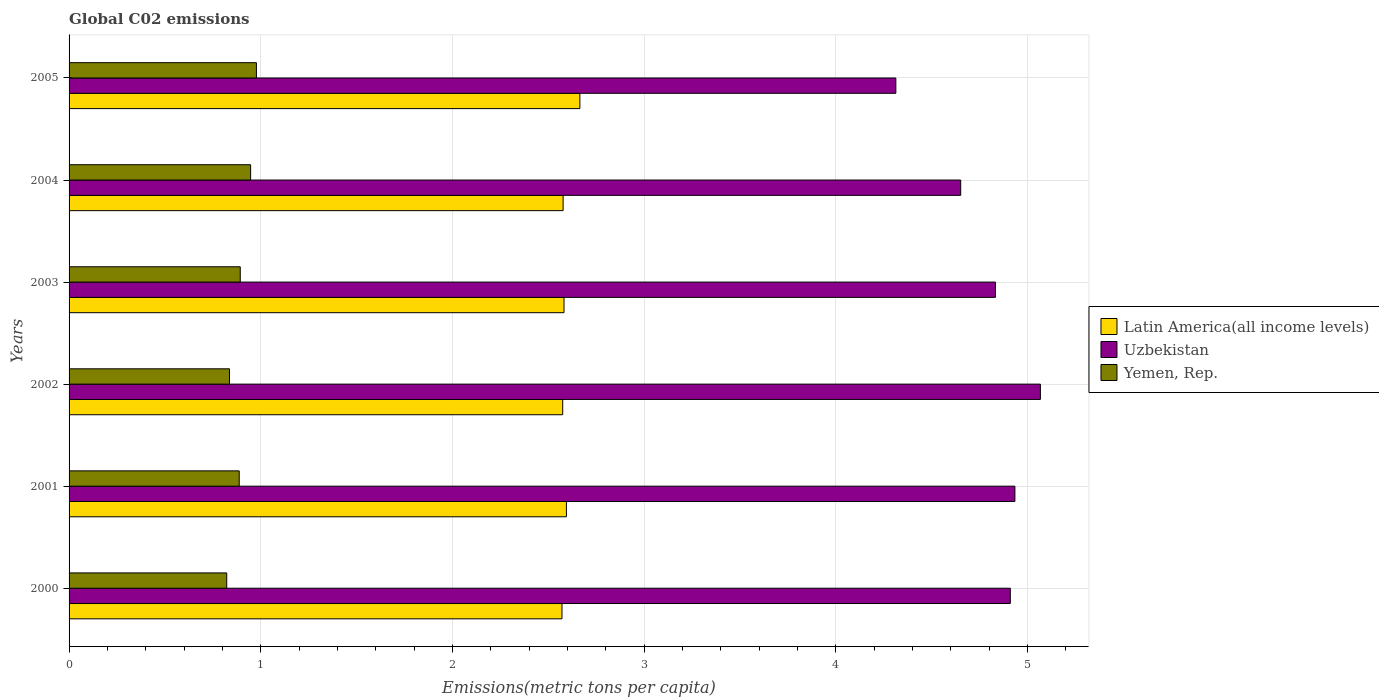How many bars are there on the 4th tick from the top?
Provide a short and direct response. 3. In how many cases, is the number of bars for a given year not equal to the number of legend labels?
Your answer should be compact. 0. What is the amount of CO2 emitted in in Uzbekistan in 2005?
Your answer should be compact. 4.31. Across all years, what is the maximum amount of CO2 emitted in in Latin America(all income levels)?
Keep it short and to the point. 2.67. Across all years, what is the minimum amount of CO2 emitted in in Latin America(all income levels)?
Make the answer very short. 2.57. In which year was the amount of CO2 emitted in in Yemen, Rep. maximum?
Your answer should be compact. 2005. What is the total amount of CO2 emitted in in Yemen, Rep. in the graph?
Give a very brief answer. 5.37. What is the difference between the amount of CO2 emitted in in Yemen, Rep. in 2001 and that in 2005?
Your answer should be compact. -0.09. What is the difference between the amount of CO2 emitted in in Uzbekistan in 2005 and the amount of CO2 emitted in in Latin America(all income levels) in 2003?
Make the answer very short. 1.73. What is the average amount of CO2 emitted in in Latin America(all income levels) per year?
Make the answer very short. 2.59. In the year 2000, what is the difference between the amount of CO2 emitted in in Yemen, Rep. and amount of CO2 emitted in in Latin America(all income levels)?
Make the answer very short. -1.75. In how many years, is the amount of CO2 emitted in in Latin America(all income levels) greater than 0.4 metric tons per capita?
Offer a very short reply. 6. What is the ratio of the amount of CO2 emitted in in Latin America(all income levels) in 2001 to that in 2003?
Ensure brevity in your answer.  1. Is the difference between the amount of CO2 emitted in in Yemen, Rep. in 2002 and 2004 greater than the difference between the amount of CO2 emitted in in Latin America(all income levels) in 2002 and 2004?
Provide a succinct answer. No. What is the difference between the highest and the second highest amount of CO2 emitted in in Latin America(all income levels)?
Your answer should be compact. 0.07. What is the difference between the highest and the lowest amount of CO2 emitted in in Uzbekistan?
Keep it short and to the point. 0.75. In how many years, is the amount of CO2 emitted in in Latin America(all income levels) greater than the average amount of CO2 emitted in in Latin America(all income levels) taken over all years?
Give a very brief answer. 2. What does the 3rd bar from the top in 2003 represents?
Offer a very short reply. Latin America(all income levels). What does the 1st bar from the bottom in 2004 represents?
Offer a very short reply. Latin America(all income levels). Is it the case that in every year, the sum of the amount of CO2 emitted in in Yemen, Rep. and amount of CO2 emitted in in Uzbekistan is greater than the amount of CO2 emitted in in Latin America(all income levels)?
Provide a short and direct response. Yes. How many bars are there?
Make the answer very short. 18. Are all the bars in the graph horizontal?
Provide a short and direct response. Yes. Are the values on the major ticks of X-axis written in scientific E-notation?
Your answer should be compact. No. Does the graph contain grids?
Make the answer very short. Yes. Where does the legend appear in the graph?
Offer a very short reply. Center right. What is the title of the graph?
Provide a short and direct response. Global C02 emissions. Does "Moldova" appear as one of the legend labels in the graph?
Your answer should be very brief. No. What is the label or title of the X-axis?
Offer a very short reply. Emissions(metric tons per capita). What is the label or title of the Y-axis?
Give a very brief answer. Years. What is the Emissions(metric tons per capita) in Latin America(all income levels) in 2000?
Offer a very short reply. 2.57. What is the Emissions(metric tons per capita) of Uzbekistan in 2000?
Offer a terse response. 4.91. What is the Emissions(metric tons per capita) in Yemen, Rep. in 2000?
Your answer should be very brief. 0.82. What is the Emissions(metric tons per capita) of Latin America(all income levels) in 2001?
Your answer should be compact. 2.59. What is the Emissions(metric tons per capita) in Uzbekistan in 2001?
Offer a very short reply. 4.94. What is the Emissions(metric tons per capita) of Yemen, Rep. in 2001?
Your answer should be compact. 0.89. What is the Emissions(metric tons per capita) in Latin America(all income levels) in 2002?
Give a very brief answer. 2.58. What is the Emissions(metric tons per capita) in Uzbekistan in 2002?
Your response must be concise. 5.07. What is the Emissions(metric tons per capita) in Yemen, Rep. in 2002?
Your answer should be very brief. 0.84. What is the Emissions(metric tons per capita) of Latin America(all income levels) in 2003?
Give a very brief answer. 2.58. What is the Emissions(metric tons per capita) in Uzbekistan in 2003?
Your response must be concise. 4.83. What is the Emissions(metric tons per capita) in Yemen, Rep. in 2003?
Provide a succinct answer. 0.89. What is the Emissions(metric tons per capita) of Latin America(all income levels) in 2004?
Keep it short and to the point. 2.58. What is the Emissions(metric tons per capita) of Uzbekistan in 2004?
Ensure brevity in your answer.  4.65. What is the Emissions(metric tons per capita) in Yemen, Rep. in 2004?
Keep it short and to the point. 0.95. What is the Emissions(metric tons per capita) of Latin America(all income levels) in 2005?
Provide a short and direct response. 2.67. What is the Emissions(metric tons per capita) of Uzbekistan in 2005?
Provide a short and direct response. 4.31. What is the Emissions(metric tons per capita) in Yemen, Rep. in 2005?
Your answer should be compact. 0.98. Across all years, what is the maximum Emissions(metric tons per capita) in Latin America(all income levels)?
Provide a succinct answer. 2.67. Across all years, what is the maximum Emissions(metric tons per capita) of Uzbekistan?
Ensure brevity in your answer.  5.07. Across all years, what is the maximum Emissions(metric tons per capita) of Yemen, Rep.?
Offer a very short reply. 0.98. Across all years, what is the minimum Emissions(metric tons per capita) of Latin America(all income levels)?
Your response must be concise. 2.57. Across all years, what is the minimum Emissions(metric tons per capita) in Uzbekistan?
Make the answer very short. 4.31. Across all years, what is the minimum Emissions(metric tons per capita) of Yemen, Rep.?
Ensure brevity in your answer.  0.82. What is the total Emissions(metric tons per capita) in Latin America(all income levels) in the graph?
Give a very brief answer. 15.57. What is the total Emissions(metric tons per capita) of Uzbekistan in the graph?
Give a very brief answer. 28.71. What is the total Emissions(metric tons per capita) of Yemen, Rep. in the graph?
Make the answer very short. 5.37. What is the difference between the Emissions(metric tons per capita) of Latin America(all income levels) in 2000 and that in 2001?
Your answer should be compact. -0.02. What is the difference between the Emissions(metric tons per capita) in Uzbekistan in 2000 and that in 2001?
Your response must be concise. -0.02. What is the difference between the Emissions(metric tons per capita) of Yemen, Rep. in 2000 and that in 2001?
Your answer should be very brief. -0.07. What is the difference between the Emissions(metric tons per capita) in Latin America(all income levels) in 2000 and that in 2002?
Your answer should be compact. -0. What is the difference between the Emissions(metric tons per capita) in Uzbekistan in 2000 and that in 2002?
Your answer should be compact. -0.16. What is the difference between the Emissions(metric tons per capita) of Yemen, Rep. in 2000 and that in 2002?
Your response must be concise. -0.01. What is the difference between the Emissions(metric tons per capita) of Latin America(all income levels) in 2000 and that in 2003?
Your response must be concise. -0.01. What is the difference between the Emissions(metric tons per capita) in Uzbekistan in 2000 and that in 2003?
Offer a terse response. 0.08. What is the difference between the Emissions(metric tons per capita) of Yemen, Rep. in 2000 and that in 2003?
Provide a succinct answer. -0.07. What is the difference between the Emissions(metric tons per capita) in Latin America(all income levels) in 2000 and that in 2004?
Make the answer very short. -0.01. What is the difference between the Emissions(metric tons per capita) in Uzbekistan in 2000 and that in 2004?
Keep it short and to the point. 0.26. What is the difference between the Emissions(metric tons per capita) in Yemen, Rep. in 2000 and that in 2004?
Offer a terse response. -0.12. What is the difference between the Emissions(metric tons per capita) of Latin America(all income levels) in 2000 and that in 2005?
Your answer should be compact. -0.09. What is the difference between the Emissions(metric tons per capita) of Uzbekistan in 2000 and that in 2005?
Offer a very short reply. 0.6. What is the difference between the Emissions(metric tons per capita) of Yemen, Rep. in 2000 and that in 2005?
Offer a very short reply. -0.15. What is the difference between the Emissions(metric tons per capita) of Latin America(all income levels) in 2001 and that in 2002?
Provide a short and direct response. 0.02. What is the difference between the Emissions(metric tons per capita) in Uzbekistan in 2001 and that in 2002?
Give a very brief answer. -0.13. What is the difference between the Emissions(metric tons per capita) in Yemen, Rep. in 2001 and that in 2002?
Provide a succinct answer. 0.05. What is the difference between the Emissions(metric tons per capita) in Latin America(all income levels) in 2001 and that in 2003?
Keep it short and to the point. 0.01. What is the difference between the Emissions(metric tons per capita) of Uzbekistan in 2001 and that in 2003?
Offer a terse response. 0.1. What is the difference between the Emissions(metric tons per capita) of Yemen, Rep. in 2001 and that in 2003?
Offer a terse response. -0.01. What is the difference between the Emissions(metric tons per capita) of Latin America(all income levels) in 2001 and that in 2004?
Give a very brief answer. 0.02. What is the difference between the Emissions(metric tons per capita) of Uzbekistan in 2001 and that in 2004?
Provide a short and direct response. 0.28. What is the difference between the Emissions(metric tons per capita) in Yemen, Rep. in 2001 and that in 2004?
Your response must be concise. -0.06. What is the difference between the Emissions(metric tons per capita) in Latin America(all income levels) in 2001 and that in 2005?
Provide a short and direct response. -0.07. What is the difference between the Emissions(metric tons per capita) in Uzbekistan in 2001 and that in 2005?
Your response must be concise. 0.62. What is the difference between the Emissions(metric tons per capita) of Yemen, Rep. in 2001 and that in 2005?
Your answer should be very brief. -0.09. What is the difference between the Emissions(metric tons per capita) in Latin America(all income levels) in 2002 and that in 2003?
Keep it short and to the point. -0.01. What is the difference between the Emissions(metric tons per capita) of Uzbekistan in 2002 and that in 2003?
Offer a very short reply. 0.23. What is the difference between the Emissions(metric tons per capita) in Yemen, Rep. in 2002 and that in 2003?
Your answer should be compact. -0.06. What is the difference between the Emissions(metric tons per capita) in Latin America(all income levels) in 2002 and that in 2004?
Make the answer very short. -0. What is the difference between the Emissions(metric tons per capita) in Uzbekistan in 2002 and that in 2004?
Your response must be concise. 0.42. What is the difference between the Emissions(metric tons per capita) of Yemen, Rep. in 2002 and that in 2004?
Your answer should be very brief. -0.11. What is the difference between the Emissions(metric tons per capita) in Latin America(all income levels) in 2002 and that in 2005?
Your response must be concise. -0.09. What is the difference between the Emissions(metric tons per capita) of Uzbekistan in 2002 and that in 2005?
Your answer should be compact. 0.75. What is the difference between the Emissions(metric tons per capita) in Yemen, Rep. in 2002 and that in 2005?
Your answer should be very brief. -0.14. What is the difference between the Emissions(metric tons per capita) in Latin America(all income levels) in 2003 and that in 2004?
Keep it short and to the point. 0. What is the difference between the Emissions(metric tons per capita) of Uzbekistan in 2003 and that in 2004?
Provide a succinct answer. 0.18. What is the difference between the Emissions(metric tons per capita) of Yemen, Rep. in 2003 and that in 2004?
Make the answer very short. -0.05. What is the difference between the Emissions(metric tons per capita) of Latin America(all income levels) in 2003 and that in 2005?
Offer a terse response. -0.08. What is the difference between the Emissions(metric tons per capita) of Uzbekistan in 2003 and that in 2005?
Ensure brevity in your answer.  0.52. What is the difference between the Emissions(metric tons per capita) of Yemen, Rep. in 2003 and that in 2005?
Offer a terse response. -0.08. What is the difference between the Emissions(metric tons per capita) of Latin America(all income levels) in 2004 and that in 2005?
Your answer should be compact. -0.09. What is the difference between the Emissions(metric tons per capita) of Uzbekistan in 2004 and that in 2005?
Your answer should be very brief. 0.34. What is the difference between the Emissions(metric tons per capita) of Yemen, Rep. in 2004 and that in 2005?
Provide a short and direct response. -0.03. What is the difference between the Emissions(metric tons per capita) of Latin America(all income levels) in 2000 and the Emissions(metric tons per capita) of Uzbekistan in 2001?
Keep it short and to the point. -2.36. What is the difference between the Emissions(metric tons per capita) in Latin America(all income levels) in 2000 and the Emissions(metric tons per capita) in Yemen, Rep. in 2001?
Give a very brief answer. 1.68. What is the difference between the Emissions(metric tons per capita) of Uzbekistan in 2000 and the Emissions(metric tons per capita) of Yemen, Rep. in 2001?
Keep it short and to the point. 4.02. What is the difference between the Emissions(metric tons per capita) of Latin America(all income levels) in 2000 and the Emissions(metric tons per capita) of Uzbekistan in 2002?
Keep it short and to the point. -2.5. What is the difference between the Emissions(metric tons per capita) in Latin America(all income levels) in 2000 and the Emissions(metric tons per capita) in Yemen, Rep. in 2002?
Ensure brevity in your answer.  1.73. What is the difference between the Emissions(metric tons per capita) in Uzbekistan in 2000 and the Emissions(metric tons per capita) in Yemen, Rep. in 2002?
Offer a terse response. 4.07. What is the difference between the Emissions(metric tons per capita) of Latin America(all income levels) in 2000 and the Emissions(metric tons per capita) of Uzbekistan in 2003?
Your answer should be compact. -2.26. What is the difference between the Emissions(metric tons per capita) of Latin America(all income levels) in 2000 and the Emissions(metric tons per capita) of Yemen, Rep. in 2003?
Ensure brevity in your answer.  1.68. What is the difference between the Emissions(metric tons per capita) of Uzbekistan in 2000 and the Emissions(metric tons per capita) of Yemen, Rep. in 2003?
Keep it short and to the point. 4.02. What is the difference between the Emissions(metric tons per capita) in Latin America(all income levels) in 2000 and the Emissions(metric tons per capita) in Uzbekistan in 2004?
Your response must be concise. -2.08. What is the difference between the Emissions(metric tons per capita) in Latin America(all income levels) in 2000 and the Emissions(metric tons per capita) in Yemen, Rep. in 2004?
Offer a terse response. 1.62. What is the difference between the Emissions(metric tons per capita) of Uzbekistan in 2000 and the Emissions(metric tons per capita) of Yemen, Rep. in 2004?
Your response must be concise. 3.96. What is the difference between the Emissions(metric tons per capita) of Latin America(all income levels) in 2000 and the Emissions(metric tons per capita) of Uzbekistan in 2005?
Ensure brevity in your answer.  -1.74. What is the difference between the Emissions(metric tons per capita) of Latin America(all income levels) in 2000 and the Emissions(metric tons per capita) of Yemen, Rep. in 2005?
Give a very brief answer. 1.59. What is the difference between the Emissions(metric tons per capita) in Uzbekistan in 2000 and the Emissions(metric tons per capita) in Yemen, Rep. in 2005?
Offer a terse response. 3.93. What is the difference between the Emissions(metric tons per capita) of Latin America(all income levels) in 2001 and the Emissions(metric tons per capita) of Uzbekistan in 2002?
Make the answer very short. -2.47. What is the difference between the Emissions(metric tons per capita) in Latin America(all income levels) in 2001 and the Emissions(metric tons per capita) in Yemen, Rep. in 2002?
Provide a succinct answer. 1.76. What is the difference between the Emissions(metric tons per capita) in Uzbekistan in 2001 and the Emissions(metric tons per capita) in Yemen, Rep. in 2002?
Make the answer very short. 4.1. What is the difference between the Emissions(metric tons per capita) in Latin America(all income levels) in 2001 and the Emissions(metric tons per capita) in Uzbekistan in 2003?
Offer a terse response. -2.24. What is the difference between the Emissions(metric tons per capita) in Latin America(all income levels) in 2001 and the Emissions(metric tons per capita) in Yemen, Rep. in 2003?
Your response must be concise. 1.7. What is the difference between the Emissions(metric tons per capita) in Uzbekistan in 2001 and the Emissions(metric tons per capita) in Yemen, Rep. in 2003?
Offer a very short reply. 4.04. What is the difference between the Emissions(metric tons per capita) in Latin America(all income levels) in 2001 and the Emissions(metric tons per capita) in Uzbekistan in 2004?
Provide a succinct answer. -2.06. What is the difference between the Emissions(metric tons per capita) in Latin America(all income levels) in 2001 and the Emissions(metric tons per capita) in Yemen, Rep. in 2004?
Provide a short and direct response. 1.65. What is the difference between the Emissions(metric tons per capita) in Uzbekistan in 2001 and the Emissions(metric tons per capita) in Yemen, Rep. in 2004?
Ensure brevity in your answer.  3.99. What is the difference between the Emissions(metric tons per capita) in Latin America(all income levels) in 2001 and the Emissions(metric tons per capita) in Uzbekistan in 2005?
Ensure brevity in your answer.  -1.72. What is the difference between the Emissions(metric tons per capita) of Latin America(all income levels) in 2001 and the Emissions(metric tons per capita) of Yemen, Rep. in 2005?
Make the answer very short. 1.62. What is the difference between the Emissions(metric tons per capita) in Uzbekistan in 2001 and the Emissions(metric tons per capita) in Yemen, Rep. in 2005?
Make the answer very short. 3.96. What is the difference between the Emissions(metric tons per capita) of Latin America(all income levels) in 2002 and the Emissions(metric tons per capita) of Uzbekistan in 2003?
Your answer should be very brief. -2.26. What is the difference between the Emissions(metric tons per capita) of Latin America(all income levels) in 2002 and the Emissions(metric tons per capita) of Yemen, Rep. in 2003?
Your answer should be very brief. 1.68. What is the difference between the Emissions(metric tons per capita) of Uzbekistan in 2002 and the Emissions(metric tons per capita) of Yemen, Rep. in 2003?
Your answer should be very brief. 4.17. What is the difference between the Emissions(metric tons per capita) of Latin America(all income levels) in 2002 and the Emissions(metric tons per capita) of Uzbekistan in 2004?
Provide a succinct answer. -2.08. What is the difference between the Emissions(metric tons per capita) of Latin America(all income levels) in 2002 and the Emissions(metric tons per capita) of Yemen, Rep. in 2004?
Give a very brief answer. 1.63. What is the difference between the Emissions(metric tons per capita) of Uzbekistan in 2002 and the Emissions(metric tons per capita) of Yemen, Rep. in 2004?
Provide a succinct answer. 4.12. What is the difference between the Emissions(metric tons per capita) of Latin America(all income levels) in 2002 and the Emissions(metric tons per capita) of Uzbekistan in 2005?
Ensure brevity in your answer.  -1.74. What is the difference between the Emissions(metric tons per capita) in Latin America(all income levels) in 2002 and the Emissions(metric tons per capita) in Yemen, Rep. in 2005?
Give a very brief answer. 1.6. What is the difference between the Emissions(metric tons per capita) in Uzbekistan in 2002 and the Emissions(metric tons per capita) in Yemen, Rep. in 2005?
Ensure brevity in your answer.  4.09. What is the difference between the Emissions(metric tons per capita) in Latin America(all income levels) in 2003 and the Emissions(metric tons per capita) in Uzbekistan in 2004?
Give a very brief answer. -2.07. What is the difference between the Emissions(metric tons per capita) in Latin America(all income levels) in 2003 and the Emissions(metric tons per capita) in Yemen, Rep. in 2004?
Keep it short and to the point. 1.64. What is the difference between the Emissions(metric tons per capita) in Uzbekistan in 2003 and the Emissions(metric tons per capita) in Yemen, Rep. in 2004?
Your response must be concise. 3.89. What is the difference between the Emissions(metric tons per capita) in Latin America(all income levels) in 2003 and the Emissions(metric tons per capita) in Uzbekistan in 2005?
Provide a succinct answer. -1.73. What is the difference between the Emissions(metric tons per capita) of Latin America(all income levels) in 2003 and the Emissions(metric tons per capita) of Yemen, Rep. in 2005?
Your answer should be compact. 1.6. What is the difference between the Emissions(metric tons per capita) in Uzbekistan in 2003 and the Emissions(metric tons per capita) in Yemen, Rep. in 2005?
Provide a short and direct response. 3.86. What is the difference between the Emissions(metric tons per capita) of Latin America(all income levels) in 2004 and the Emissions(metric tons per capita) of Uzbekistan in 2005?
Give a very brief answer. -1.74. What is the difference between the Emissions(metric tons per capita) of Latin America(all income levels) in 2004 and the Emissions(metric tons per capita) of Yemen, Rep. in 2005?
Offer a terse response. 1.6. What is the difference between the Emissions(metric tons per capita) of Uzbekistan in 2004 and the Emissions(metric tons per capita) of Yemen, Rep. in 2005?
Offer a very short reply. 3.67. What is the average Emissions(metric tons per capita) of Latin America(all income levels) per year?
Keep it short and to the point. 2.59. What is the average Emissions(metric tons per capita) in Uzbekistan per year?
Your answer should be compact. 4.79. What is the average Emissions(metric tons per capita) of Yemen, Rep. per year?
Give a very brief answer. 0.89. In the year 2000, what is the difference between the Emissions(metric tons per capita) in Latin America(all income levels) and Emissions(metric tons per capita) in Uzbekistan?
Provide a succinct answer. -2.34. In the year 2000, what is the difference between the Emissions(metric tons per capita) of Latin America(all income levels) and Emissions(metric tons per capita) of Yemen, Rep.?
Provide a succinct answer. 1.75. In the year 2000, what is the difference between the Emissions(metric tons per capita) of Uzbekistan and Emissions(metric tons per capita) of Yemen, Rep.?
Keep it short and to the point. 4.09. In the year 2001, what is the difference between the Emissions(metric tons per capita) in Latin America(all income levels) and Emissions(metric tons per capita) in Uzbekistan?
Keep it short and to the point. -2.34. In the year 2001, what is the difference between the Emissions(metric tons per capita) in Latin America(all income levels) and Emissions(metric tons per capita) in Yemen, Rep.?
Offer a terse response. 1.71. In the year 2001, what is the difference between the Emissions(metric tons per capita) of Uzbekistan and Emissions(metric tons per capita) of Yemen, Rep.?
Provide a succinct answer. 4.05. In the year 2002, what is the difference between the Emissions(metric tons per capita) of Latin America(all income levels) and Emissions(metric tons per capita) of Uzbekistan?
Your answer should be very brief. -2.49. In the year 2002, what is the difference between the Emissions(metric tons per capita) of Latin America(all income levels) and Emissions(metric tons per capita) of Yemen, Rep.?
Provide a short and direct response. 1.74. In the year 2002, what is the difference between the Emissions(metric tons per capita) in Uzbekistan and Emissions(metric tons per capita) in Yemen, Rep.?
Give a very brief answer. 4.23. In the year 2003, what is the difference between the Emissions(metric tons per capita) of Latin America(all income levels) and Emissions(metric tons per capita) of Uzbekistan?
Keep it short and to the point. -2.25. In the year 2003, what is the difference between the Emissions(metric tons per capita) of Latin America(all income levels) and Emissions(metric tons per capita) of Yemen, Rep.?
Your answer should be very brief. 1.69. In the year 2003, what is the difference between the Emissions(metric tons per capita) of Uzbekistan and Emissions(metric tons per capita) of Yemen, Rep.?
Give a very brief answer. 3.94. In the year 2004, what is the difference between the Emissions(metric tons per capita) of Latin America(all income levels) and Emissions(metric tons per capita) of Uzbekistan?
Your answer should be very brief. -2.07. In the year 2004, what is the difference between the Emissions(metric tons per capita) in Latin America(all income levels) and Emissions(metric tons per capita) in Yemen, Rep.?
Your answer should be compact. 1.63. In the year 2004, what is the difference between the Emissions(metric tons per capita) of Uzbekistan and Emissions(metric tons per capita) of Yemen, Rep.?
Ensure brevity in your answer.  3.7. In the year 2005, what is the difference between the Emissions(metric tons per capita) of Latin America(all income levels) and Emissions(metric tons per capita) of Uzbekistan?
Make the answer very short. -1.65. In the year 2005, what is the difference between the Emissions(metric tons per capita) in Latin America(all income levels) and Emissions(metric tons per capita) in Yemen, Rep.?
Your response must be concise. 1.69. In the year 2005, what is the difference between the Emissions(metric tons per capita) in Uzbekistan and Emissions(metric tons per capita) in Yemen, Rep.?
Provide a succinct answer. 3.34. What is the ratio of the Emissions(metric tons per capita) in Uzbekistan in 2000 to that in 2001?
Offer a very short reply. 1. What is the ratio of the Emissions(metric tons per capita) of Yemen, Rep. in 2000 to that in 2001?
Your answer should be very brief. 0.93. What is the ratio of the Emissions(metric tons per capita) in Latin America(all income levels) in 2000 to that in 2002?
Offer a terse response. 1. What is the ratio of the Emissions(metric tons per capita) in Yemen, Rep. in 2000 to that in 2002?
Provide a short and direct response. 0.98. What is the ratio of the Emissions(metric tons per capita) in Latin America(all income levels) in 2000 to that in 2003?
Your response must be concise. 1. What is the ratio of the Emissions(metric tons per capita) of Uzbekistan in 2000 to that in 2003?
Keep it short and to the point. 1.02. What is the ratio of the Emissions(metric tons per capita) in Yemen, Rep. in 2000 to that in 2003?
Make the answer very short. 0.92. What is the ratio of the Emissions(metric tons per capita) in Uzbekistan in 2000 to that in 2004?
Your answer should be very brief. 1.06. What is the ratio of the Emissions(metric tons per capita) of Yemen, Rep. in 2000 to that in 2004?
Your answer should be compact. 0.87. What is the ratio of the Emissions(metric tons per capita) of Uzbekistan in 2000 to that in 2005?
Your answer should be compact. 1.14. What is the ratio of the Emissions(metric tons per capita) in Yemen, Rep. in 2000 to that in 2005?
Offer a terse response. 0.84. What is the ratio of the Emissions(metric tons per capita) of Latin America(all income levels) in 2001 to that in 2002?
Your answer should be very brief. 1.01. What is the ratio of the Emissions(metric tons per capita) in Uzbekistan in 2001 to that in 2002?
Give a very brief answer. 0.97. What is the ratio of the Emissions(metric tons per capita) in Yemen, Rep. in 2001 to that in 2002?
Your answer should be very brief. 1.06. What is the ratio of the Emissions(metric tons per capita) of Latin America(all income levels) in 2001 to that in 2003?
Your answer should be very brief. 1. What is the ratio of the Emissions(metric tons per capita) of Yemen, Rep. in 2001 to that in 2003?
Provide a short and direct response. 0.99. What is the ratio of the Emissions(metric tons per capita) of Latin America(all income levels) in 2001 to that in 2004?
Your answer should be very brief. 1.01. What is the ratio of the Emissions(metric tons per capita) in Uzbekistan in 2001 to that in 2004?
Provide a short and direct response. 1.06. What is the ratio of the Emissions(metric tons per capita) in Yemen, Rep. in 2001 to that in 2004?
Provide a succinct answer. 0.94. What is the ratio of the Emissions(metric tons per capita) in Latin America(all income levels) in 2001 to that in 2005?
Make the answer very short. 0.97. What is the ratio of the Emissions(metric tons per capita) of Uzbekistan in 2001 to that in 2005?
Your answer should be very brief. 1.14. What is the ratio of the Emissions(metric tons per capita) of Yemen, Rep. in 2001 to that in 2005?
Offer a very short reply. 0.91. What is the ratio of the Emissions(metric tons per capita) in Uzbekistan in 2002 to that in 2003?
Provide a succinct answer. 1.05. What is the ratio of the Emissions(metric tons per capita) of Yemen, Rep. in 2002 to that in 2003?
Offer a terse response. 0.94. What is the ratio of the Emissions(metric tons per capita) of Uzbekistan in 2002 to that in 2004?
Offer a terse response. 1.09. What is the ratio of the Emissions(metric tons per capita) in Yemen, Rep. in 2002 to that in 2004?
Your answer should be very brief. 0.88. What is the ratio of the Emissions(metric tons per capita) in Latin America(all income levels) in 2002 to that in 2005?
Your response must be concise. 0.97. What is the ratio of the Emissions(metric tons per capita) in Uzbekistan in 2002 to that in 2005?
Offer a terse response. 1.17. What is the ratio of the Emissions(metric tons per capita) in Yemen, Rep. in 2002 to that in 2005?
Offer a terse response. 0.86. What is the ratio of the Emissions(metric tons per capita) in Uzbekistan in 2003 to that in 2004?
Provide a short and direct response. 1.04. What is the ratio of the Emissions(metric tons per capita) of Yemen, Rep. in 2003 to that in 2004?
Provide a succinct answer. 0.94. What is the ratio of the Emissions(metric tons per capita) in Latin America(all income levels) in 2003 to that in 2005?
Provide a succinct answer. 0.97. What is the ratio of the Emissions(metric tons per capita) of Uzbekistan in 2003 to that in 2005?
Your response must be concise. 1.12. What is the ratio of the Emissions(metric tons per capita) of Yemen, Rep. in 2003 to that in 2005?
Your response must be concise. 0.91. What is the ratio of the Emissions(metric tons per capita) in Latin America(all income levels) in 2004 to that in 2005?
Your answer should be very brief. 0.97. What is the ratio of the Emissions(metric tons per capita) in Uzbekistan in 2004 to that in 2005?
Your answer should be compact. 1.08. What is the ratio of the Emissions(metric tons per capita) in Yemen, Rep. in 2004 to that in 2005?
Ensure brevity in your answer.  0.97. What is the difference between the highest and the second highest Emissions(metric tons per capita) in Latin America(all income levels)?
Your answer should be compact. 0.07. What is the difference between the highest and the second highest Emissions(metric tons per capita) of Uzbekistan?
Ensure brevity in your answer.  0.13. What is the difference between the highest and the second highest Emissions(metric tons per capita) of Yemen, Rep.?
Provide a short and direct response. 0.03. What is the difference between the highest and the lowest Emissions(metric tons per capita) of Latin America(all income levels)?
Make the answer very short. 0.09. What is the difference between the highest and the lowest Emissions(metric tons per capita) in Uzbekistan?
Offer a terse response. 0.75. What is the difference between the highest and the lowest Emissions(metric tons per capita) of Yemen, Rep.?
Your answer should be very brief. 0.15. 